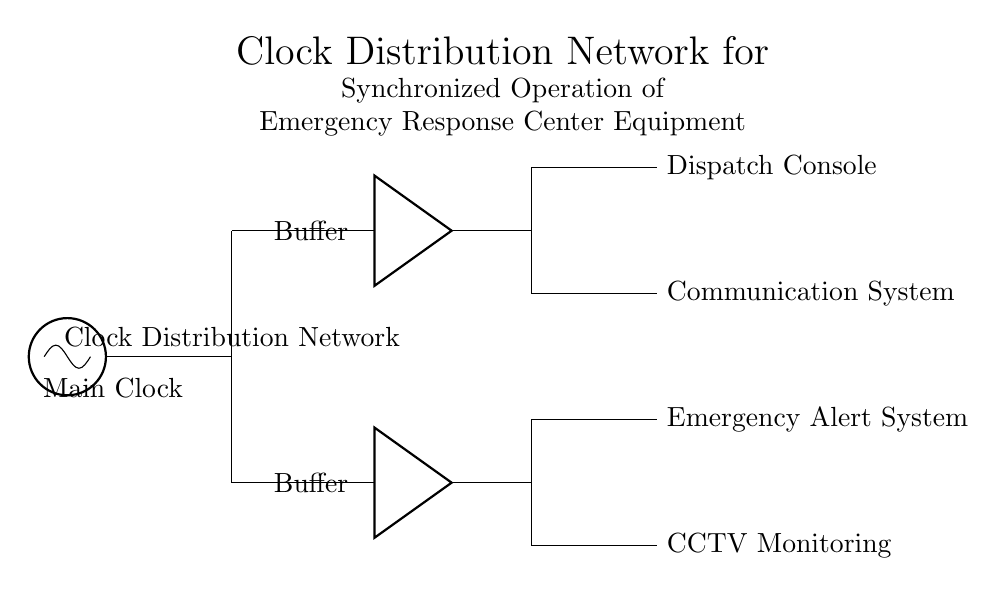What is the main component of this clock distribution network? The main component is the oscillator labeled as "Main Clock," which generates the clock signal for distribution.
Answer: Main Clock How many buffers are present in the circuit? There are two buffers, one for each branch of the distribution network, labeled as "Buffer."
Answer: Two What are the connected equipment items in the upper branch? The upper branch connects to the "Dispatch Console" and the "Communication System," which both receive the clock signal from the respective buffer outputs.
Answer: Dispatch Console, Communication System Which system is connected in the lower branch? The lower branch connects to the "Emergency Alert System" and "CCTV Monitoring," indicating that these systems rely on the clock signal for synchronized operation.
Answer: Emergency Alert System, CCTV Monitoring What is the purpose of the buffers in this circuit? The buffers are used to strengthen the clock signal for distribution to the connected equipment, ensuring minimal signal degradation over the connections.
Answer: Signal amplification What does the label "Clock Distribution Network" signify? It signifies the purpose of the circuit, which is to distribute the clock signal from the main oscillator to various emergency response equipment, ensuring they operate in synchronization.
Answer: Distribution of the clock signal What type of circuit is depicted in this diagram? This is a synchronous circuit, as it relies on a common clock signal to synchronize the operation of multiple connected systems.
Answer: Synchronous 